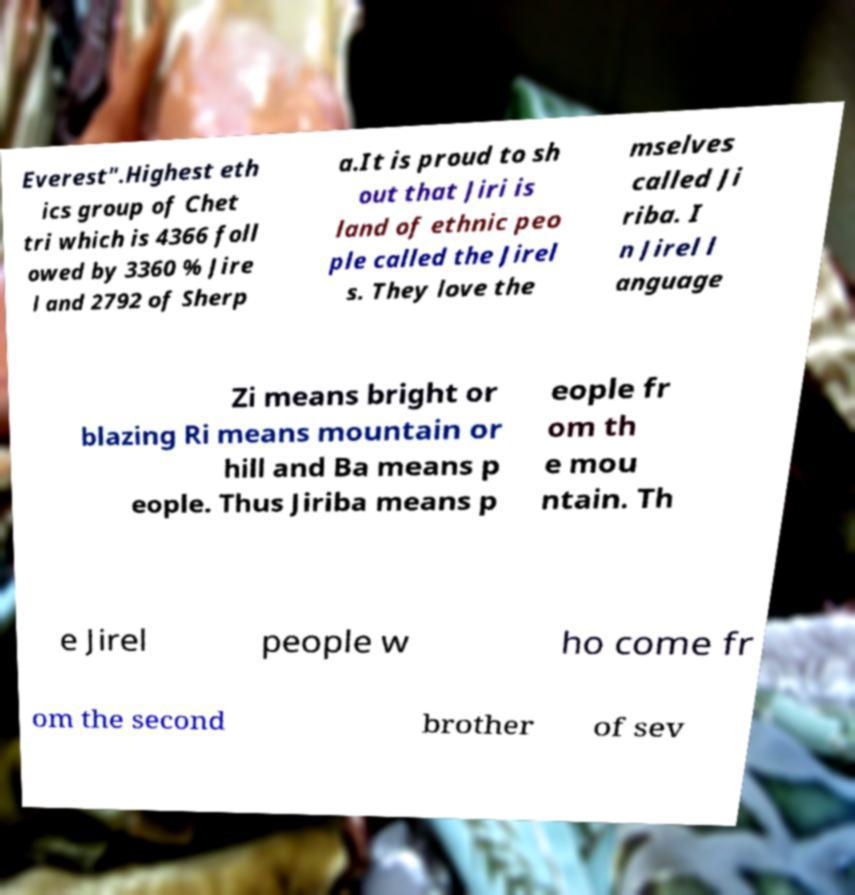For documentation purposes, I need the text within this image transcribed. Could you provide that? Everest".Highest eth ics group of Chet tri which is 4366 foll owed by 3360 % Jire l and 2792 of Sherp a.It is proud to sh out that Jiri is land of ethnic peo ple called the Jirel s. They love the mselves called Ji riba. I n Jirel l anguage Zi means bright or blazing Ri means mountain or hill and Ba means p eople. Thus Jiriba means p eople fr om th e mou ntain. Th e Jirel people w ho come fr om the second brother of sev 